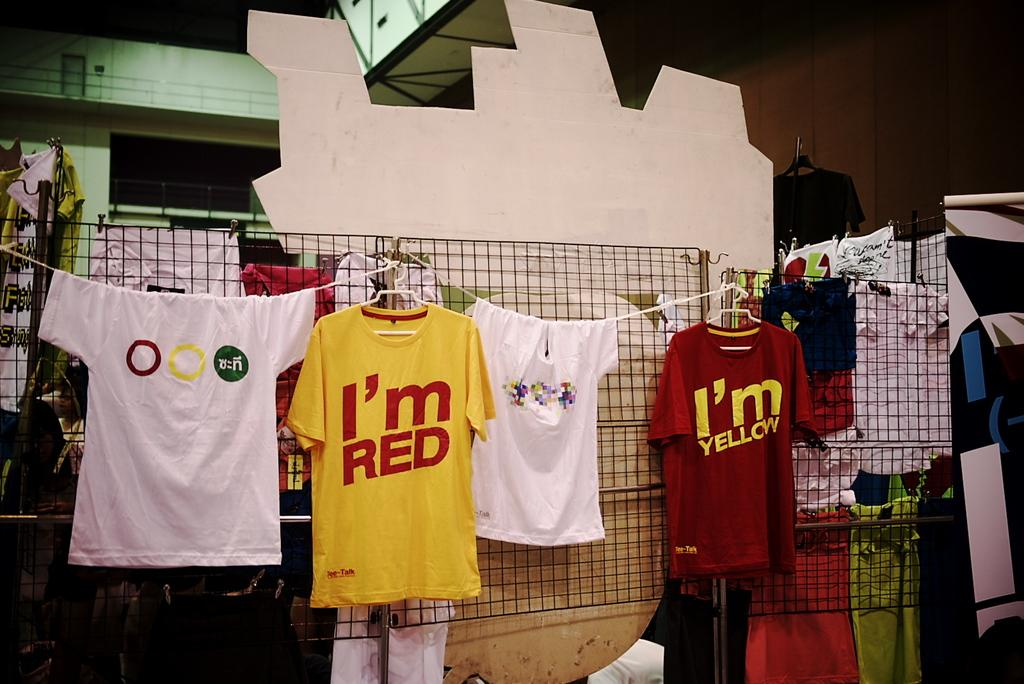<image>
Describe the image concisely. Several t-shirts hang on a line inside a room, one yellow t-shirt has the words I'm red on its from and a red one says I'm yellow. 